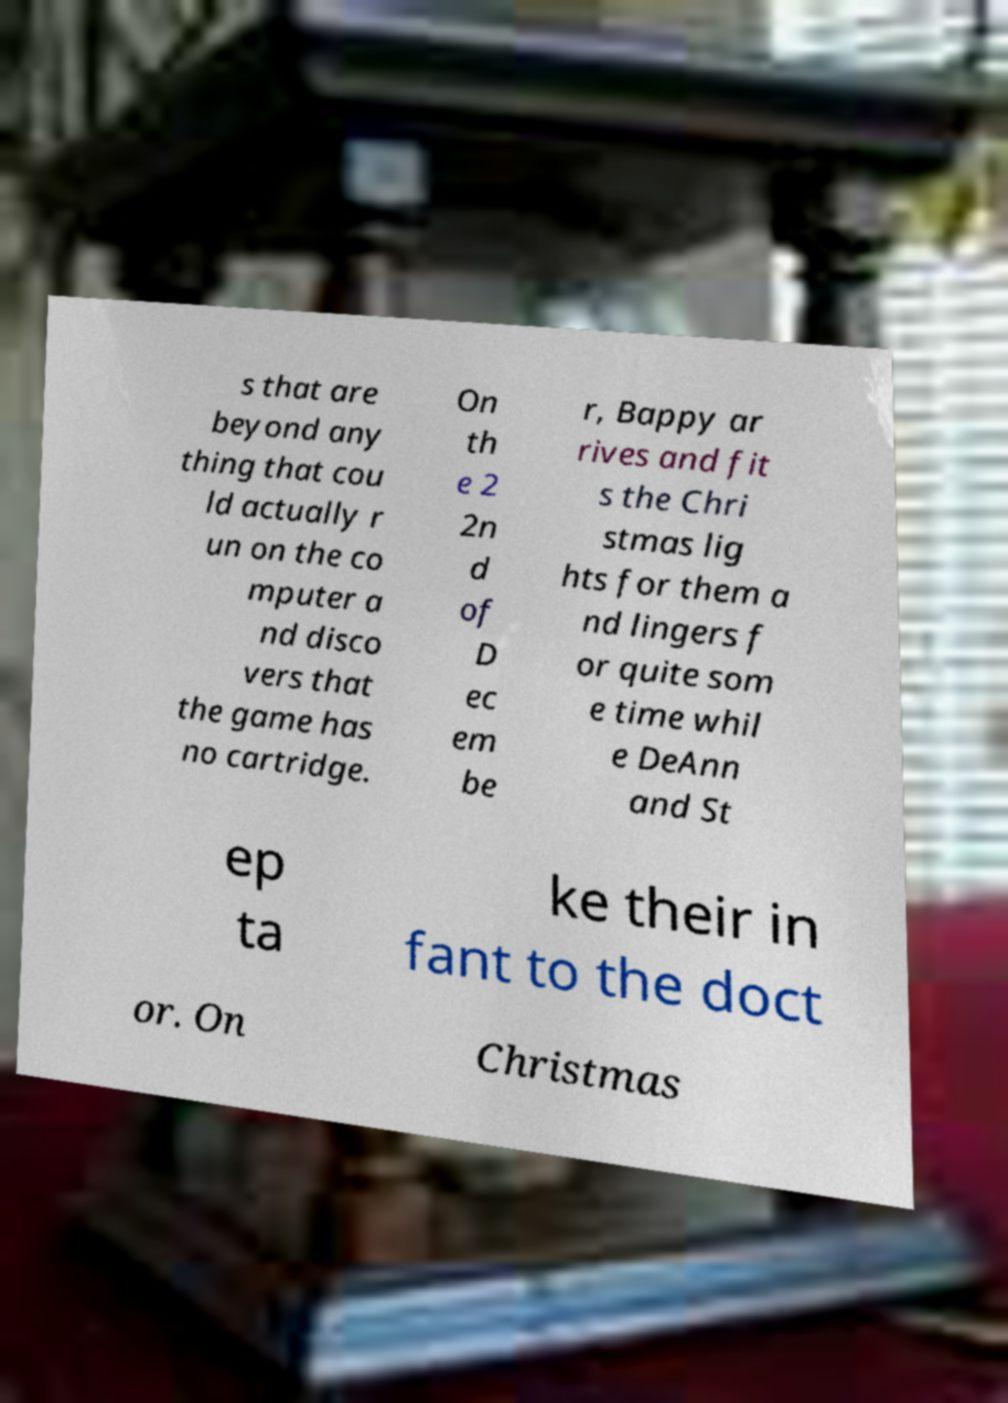I need the written content from this picture converted into text. Can you do that? s that are beyond any thing that cou ld actually r un on the co mputer a nd disco vers that the game has no cartridge. On th e 2 2n d of D ec em be r, Bappy ar rives and fit s the Chri stmas lig hts for them a nd lingers f or quite som e time whil e DeAnn and St ep ta ke their in fant to the doct or. On Christmas 